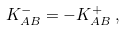Convert formula to latex. <formula><loc_0><loc_0><loc_500><loc_500>K _ { A B } ^ { - } = - K _ { A B } ^ { + } \, ,</formula> 